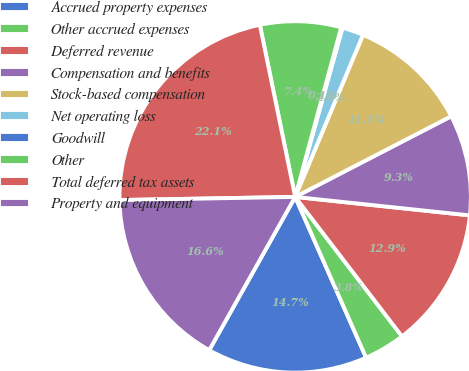<chart> <loc_0><loc_0><loc_500><loc_500><pie_chart><fcel>Accrued property expenses<fcel>Other accrued expenses<fcel>Deferred revenue<fcel>Compensation and benefits<fcel>Stock-based compensation<fcel>Net operating loss<fcel>Goodwill<fcel>Other<fcel>Total deferred tax assets<fcel>Property and equipment<nl><fcel>14.75%<fcel>3.79%<fcel>12.92%<fcel>9.27%<fcel>11.1%<fcel>1.96%<fcel>0.13%<fcel>7.44%<fcel>22.06%<fcel>16.58%<nl></chart> 